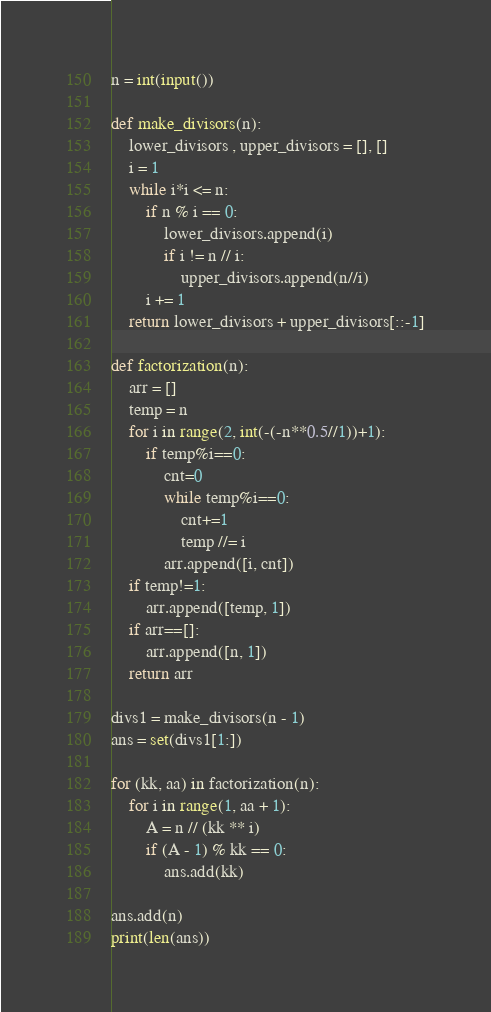Convert code to text. <code><loc_0><loc_0><loc_500><loc_500><_Python_>n = int(input())

def make_divisors(n):
    lower_divisors , upper_divisors = [], []
    i = 1
    while i*i <= n:
        if n % i == 0:
            lower_divisors.append(i)
            if i != n // i:
                upper_divisors.append(n//i)
        i += 1
    return lower_divisors + upper_divisors[::-1]

def factorization(n):
    arr = []
    temp = n
    for i in range(2, int(-(-n**0.5//1))+1):
        if temp%i==0:
            cnt=0
            while temp%i==0:
                cnt+=1
                temp //= i
            arr.append([i, cnt])
    if temp!=1:
        arr.append([temp, 1])
    if arr==[]:
        arr.append([n, 1])
    return arr

divs1 = make_divisors(n - 1)
ans = set(divs1[1:])

for (kk, aa) in factorization(n):
    for i in range(1, aa + 1):
        A = n // (kk ** i)
        if (A - 1) % kk == 0:
            ans.add(kk)

ans.add(n)
print(len(ans))
</code> 